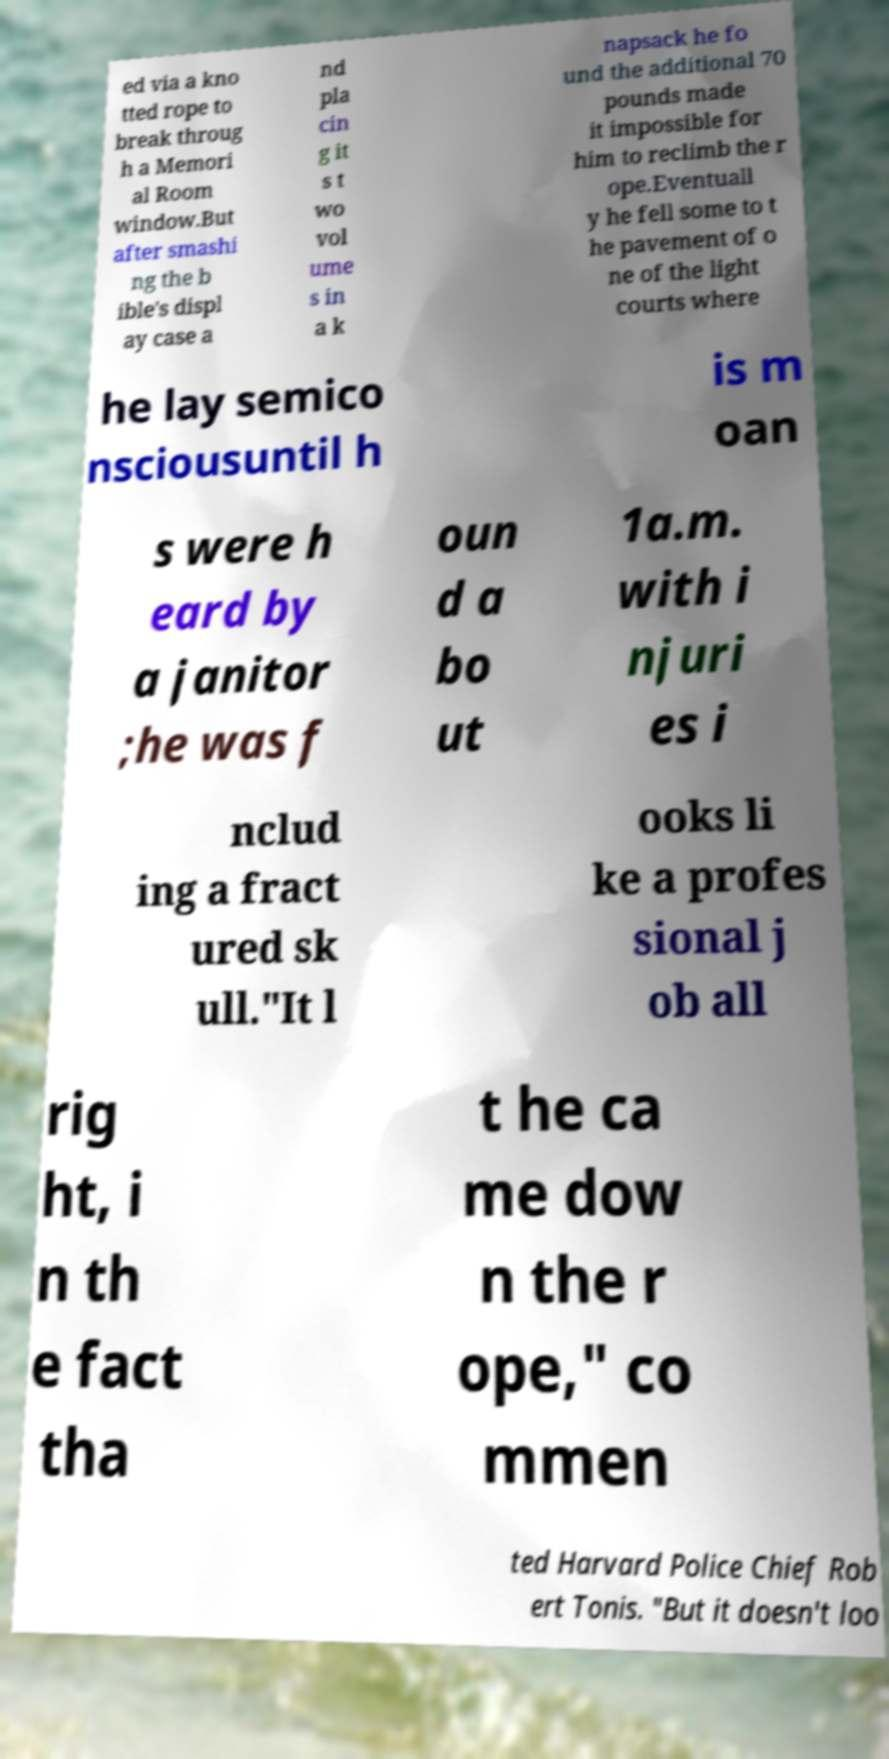What messages or text are displayed in this image? I need them in a readable, typed format. ed via a kno tted rope to break throug h a Memori al Room window.But after smashi ng the b ible's displ ay case a nd pla cin g it s t wo vol ume s in a k napsack he fo und the additional 70 pounds made it impossible for him to reclimb the r ope.Eventuall y he fell some to t he pavement of o ne of the light courts where he lay semico nsciousuntil h is m oan s were h eard by a janitor ;he was f oun d a bo ut 1a.m. with i njuri es i nclud ing a fract ured sk ull."It l ooks li ke a profes sional j ob all rig ht, i n th e fact tha t he ca me dow n the r ope," co mmen ted Harvard Police Chief Rob ert Tonis. "But it doesn't loo 